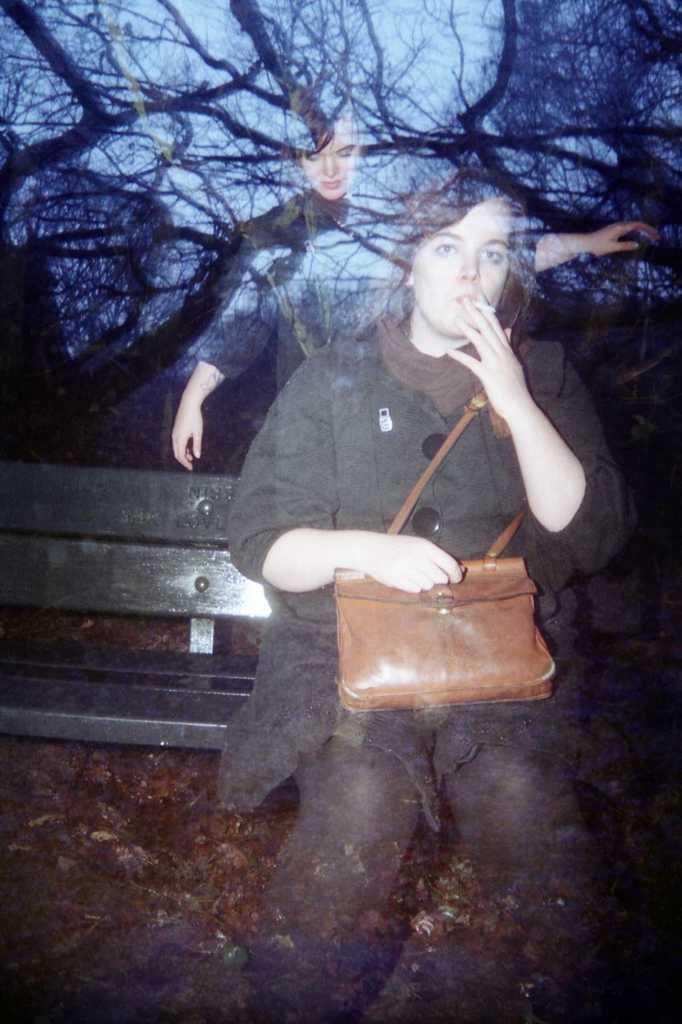In one or two sentences, can you explain what this image depicts? In this image there is a woman sitting on the bench by holding the bag with one hand and holding the cigar with another hand. In the background there are trees. In front, there is a mirror on which there are reflections. 